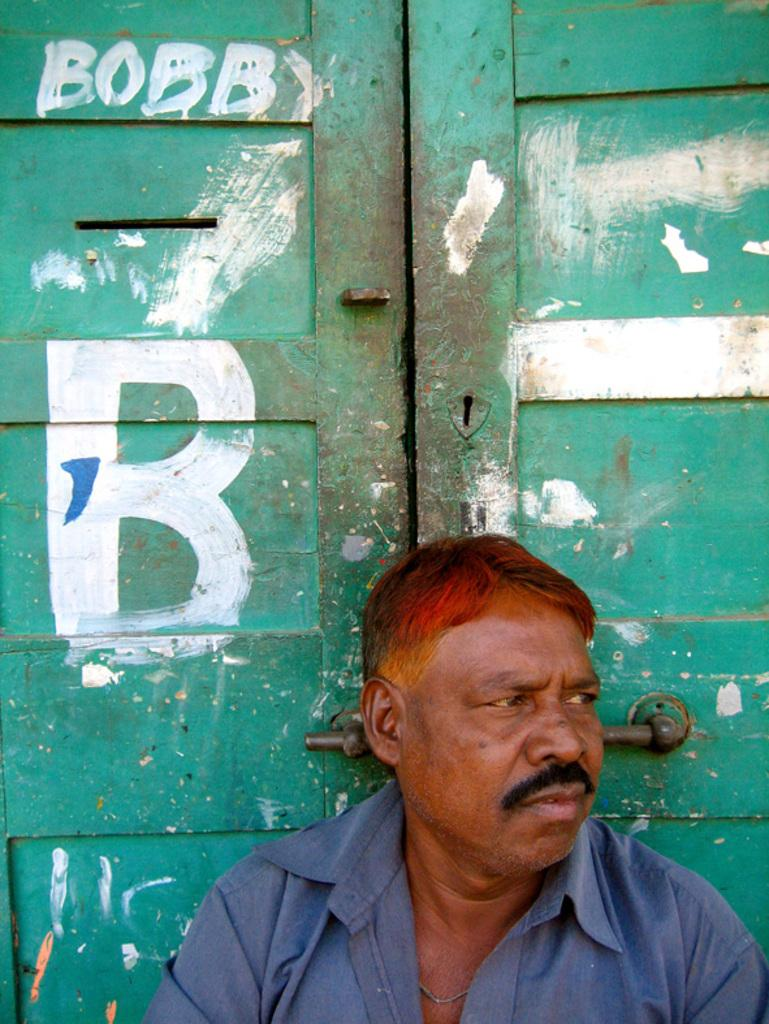Who is present in the image? There is a man in the picture. What is the man wearing? The man is wearing a shirt. What can be seen behind the man? There is text on a door behind the man. How many feet are visible in the image? There are no feet visible in the image; it only shows a man wearing a shirt with text on a door behind him. 